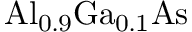<formula> <loc_0><loc_0><loc_500><loc_500>{ A l _ { 0 . 9 } G a _ { 0 . 1 } A s }</formula> 